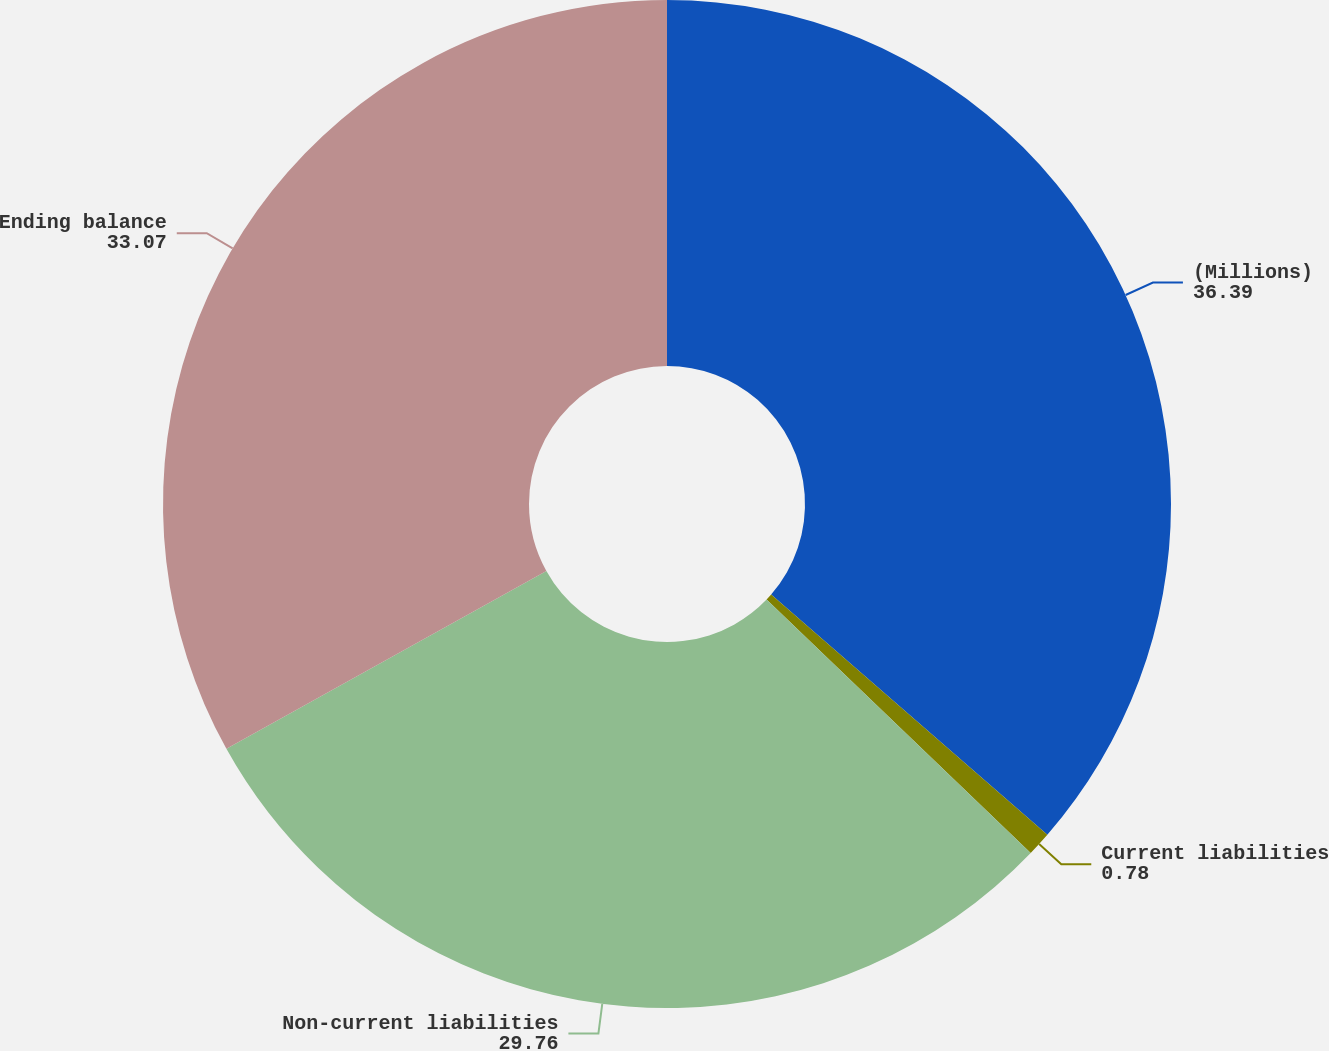Convert chart. <chart><loc_0><loc_0><loc_500><loc_500><pie_chart><fcel>(Millions)<fcel>Current liabilities<fcel>Non-current liabilities<fcel>Ending balance<nl><fcel>36.39%<fcel>0.78%<fcel>29.76%<fcel>33.07%<nl></chart> 